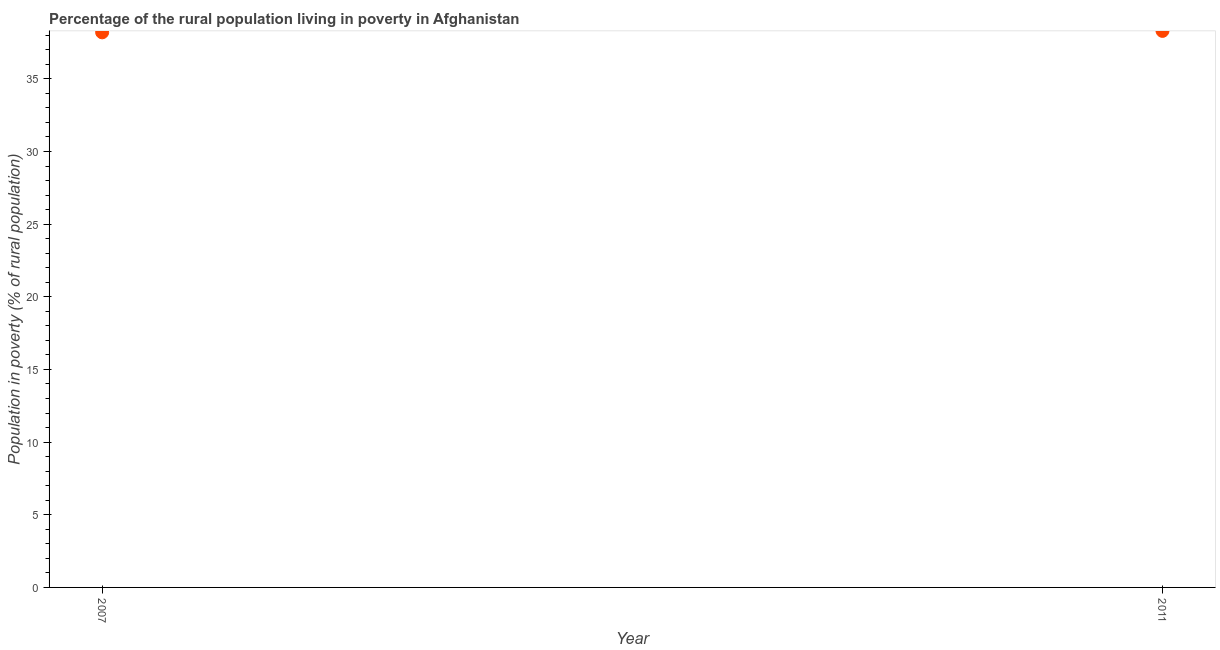What is the percentage of rural population living below poverty line in 2011?
Your answer should be very brief. 38.3. Across all years, what is the maximum percentage of rural population living below poverty line?
Your answer should be compact. 38.3. Across all years, what is the minimum percentage of rural population living below poverty line?
Your answer should be compact. 38.2. In which year was the percentage of rural population living below poverty line maximum?
Make the answer very short. 2011. What is the sum of the percentage of rural population living below poverty line?
Your answer should be very brief. 76.5. What is the difference between the percentage of rural population living below poverty line in 2007 and 2011?
Ensure brevity in your answer.  -0.1. What is the average percentage of rural population living below poverty line per year?
Offer a terse response. 38.25. What is the median percentage of rural population living below poverty line?
Ensure brevity in your answer.  38.25. In how many years, is the percentage of rural population living below poverty line greater than 11 %?
Keep it short and to the point. 2. Do a majority of the years between 2011 and 2007 (inclusive) have percentage of rural population living below poverty line greater than 10 %?
Keep it short and to the point. No. What is the ratio of the percentage of rural population living below poverty line in 2007 to that in 2011?
Offer a very short reply. 1. Is the percentage of rural population living below poverty line in 2007 less than that in 2011?
Your response must be concise. Yes. In how many years, is the percentage of rural population living below poverty line greater than the average percentage of rural population living below poverty line taken over all years?
Your answer should be very brief. 1. Does the percentage of rural population living below poverty line monotonically increase over the years?
Keep it short and to the point. Yes. How many years are there in the graph?
Ensure brevity in your answer.  2. What is the difference between two consecutive major ticks on the Y-axis?
Keep it short and to the point. 5. Are the values on the major ticks of Y-axis written in scientific E-notation?
Provide a short and direct response. No. Does the graph contain any zero values?
Give a very brief answer. No. Does the graph contain grids?
Your answer should be very brief. No. What is the title of the graph?
Offer a very short reply. Percentage of the rural population living in poverty in Afghanistan. What is the label or title of the Y-axis?
Your answer should be very brief. Population in poverty (% of rural population). What is the Population in poverty (% of rural population) in 2007?
Make the answer very short. 38.2. What is the Population in poverty (% of rural population) in 2011?
Keep it short and to the point. 38.3. What is the difference between the Population in poverty (% of rural population) in 2007 and 2011?
Your response must be concise. -0.1. What is the ratio of the Population in poverty (% of rural population) in 2007 to that in 2011?
Give a very brief answer. 1. 